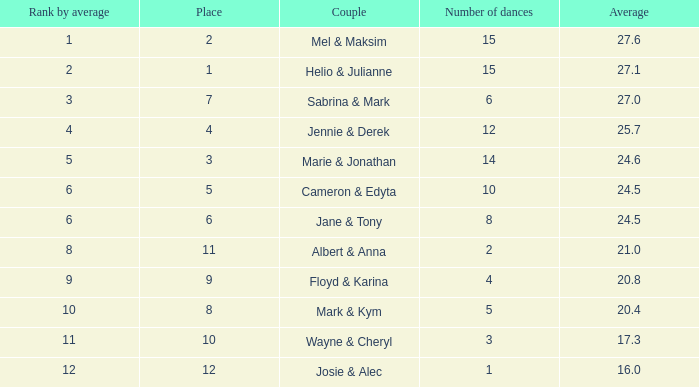What is the lowest position number when the overall amount is 16 and the average is under 16? None. 